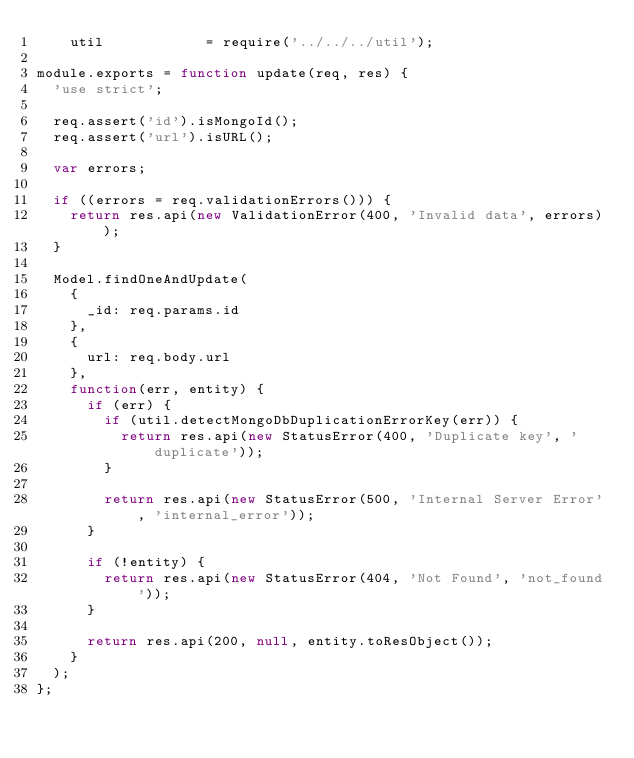Convert code to text. <code><loc_0><loc_0><loc_500><loc_500><_JavaScript_>    util            = require('../../../util');

module.exports = function update(req, res) {
  'use strict';

  req.assert('id').isMongoId();
  req.assert('url').isURL();

  var errors;

  if ((errors = req.validationErrors())) {
    return res.api(new ValidationError(400, 'Invalid data', errors));
  }

  Model.findOneAndUpdate(
    {
      _id: req.params.id
    },
    {
      url: req.body.url
    },
    function(err, entity) {
      if (err) {
        if (util.detectMongoDbDuplicationErrorKey(err)) {
          return res.api(new StatusError(400, 'Duplicate key', 'duplicate'));
        }

        return res.api(new StatusError(500, 'Internal Server Error', 'internal_error'));
      }

      if (!entity) {
        return res.api(new StatusError(404, 'Not Found', 'not_found'));
      }

      return res.api(200, null, entity.toResObject());
    }
  );
};</code> 